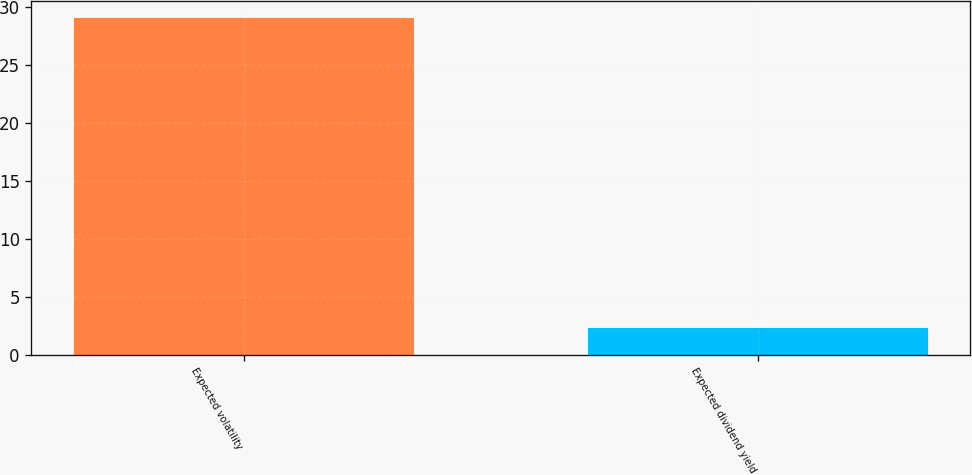Convert chart to OTSL. <chart><loc_0><loc_0><loc_500><loc_500><bar_chart><fcel>Expected volatility<fcel>Expected dividend yield<nl><fcel>29<fcel>2.3<nl></chart> 